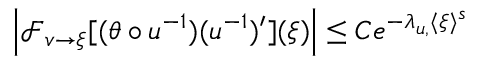<formula> <loc_0><loc_0><loc_500><loc_500>\begin{array} { r } { \left | \mathcal { F } _ { v \to \xi } [ ( \theta \circ u ^ { - 1 } ) ( u ^ { - 1 } ) ^ { \prime } ] ( \xi ) \right | \leq C e ^ { - \lambda _ { u , \ t h } \langle \xi \rangle ^ { s } } } \end{array}</formula> 